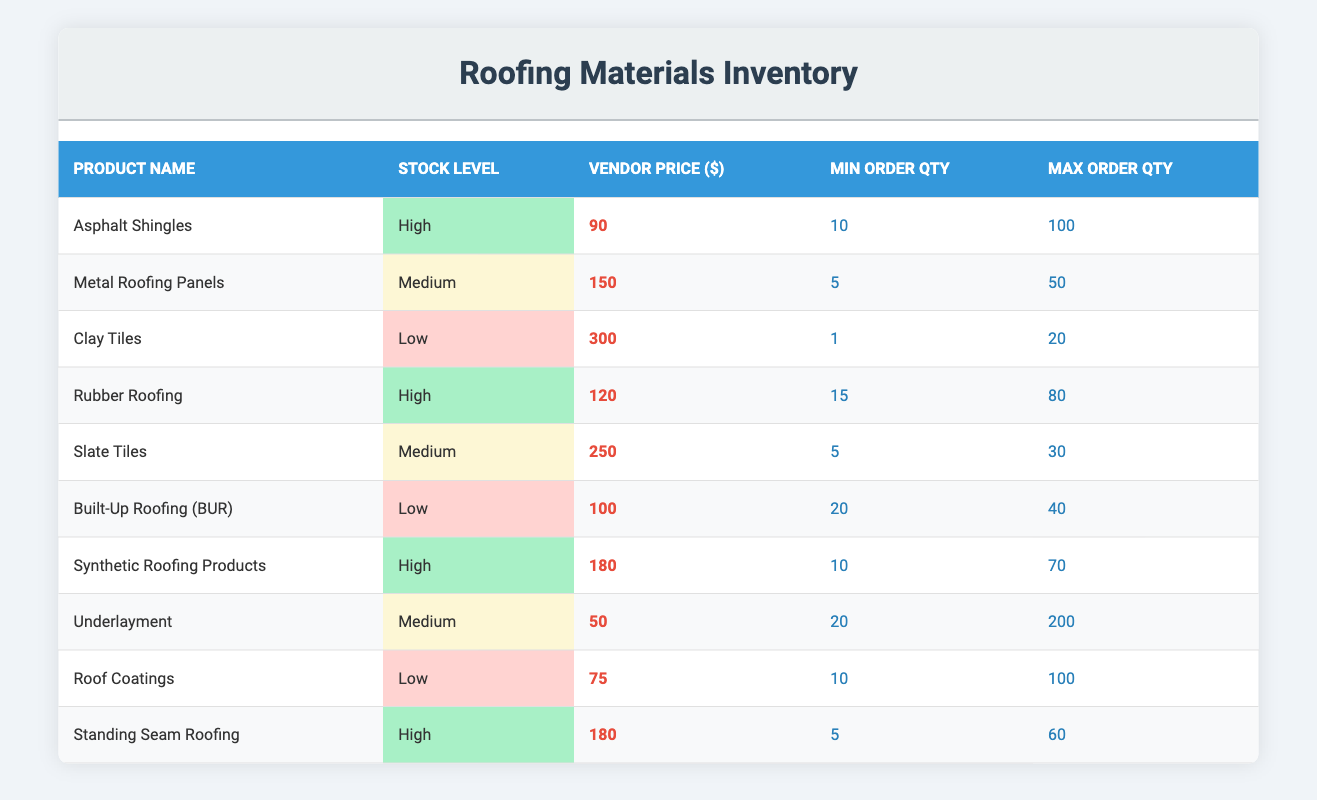What is the vendor price of Asphalt Shingles? The table lists the vendor price for Asphalt Shingles, which is 90.
Answer: 90 How many roofing materials have a medium stock level? Looking at the table, Metal Roofing Panels, Slate Tiles, and Underlayment are identified as having a medium stock level, totaling three products.
Answer: 3 Is the vendor price of Rubber Roofing lower than that of Slate Tiles? The vendor price for Rubber Roofing is 120, while for Slate Tiles, it is 250. Since 120 is less than 250, the answer is yes.
Answer: Yes What is the maximum order quantity for Built-Up Roofing (BUR)? The table shows that the maximum order quantity for Built-Up Roofing (BUR) is listed as 40.
Answer: 40 Which product has the highest vendor price? By examining the vendor prices across all products, Clay Tiles has the highest price at 300.
Answer: Clay Tiles What is the average vendor price for materials with high stock levels? The vendor prices for products with high stock levels are 90 (Asphalt Shingles), 120 (Rubber Roofing), 180 (Synthetic Roofing Products), and 180 (Standing Seam Roofing). Summing these prices gives 90 + 120 + 180 + 180 = 570. There are 4 products, so the average is 570 / 4 = 142.5.
Answer: 142.5 Are there any products where the minimum order quantity is less than 5? Reviewing the minimum order quantities, the values are 10, 5, 1, 15, 5, 20, 10, 20, 10, and 5. Since one product (Clay Tiles) has a minimum order quantity of 1, the answer is yes.
Answer: Yes How many products have a stock level classified as low? The table indicates that Clay Tiles, Built-Up Roofing (BUR), and Roof Coatings are classified as low, leading to a total of three products.
Answer: 3 If I order the maximum quantity of Synthetic Roofing Products, how many units will I receive? The maximum order quantity for Synthetic Roofing Products is 70, so if you order this amount, you will receive 70 units.
Answer: 70 